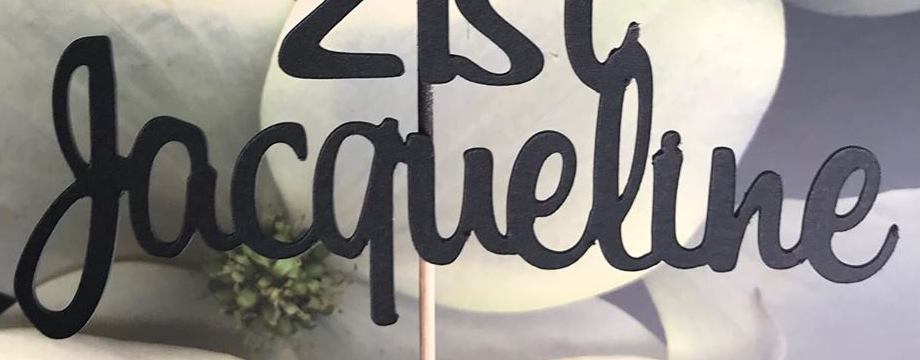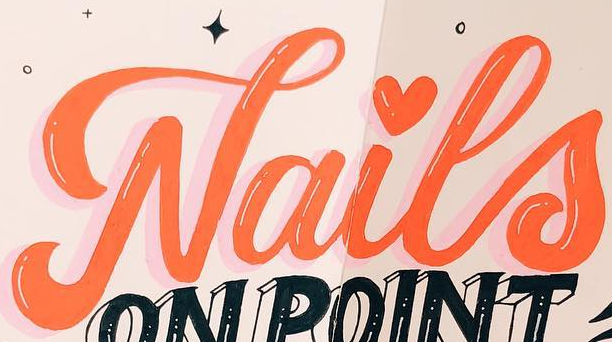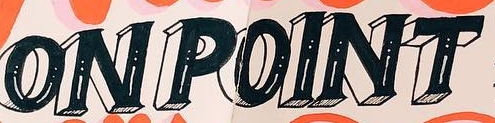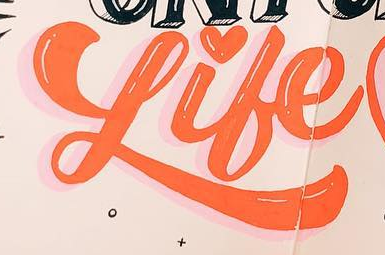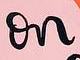What words are shown in these images in order, separated by a semicolon? Jacqueline; Nails; ONPOINT; Like; on 